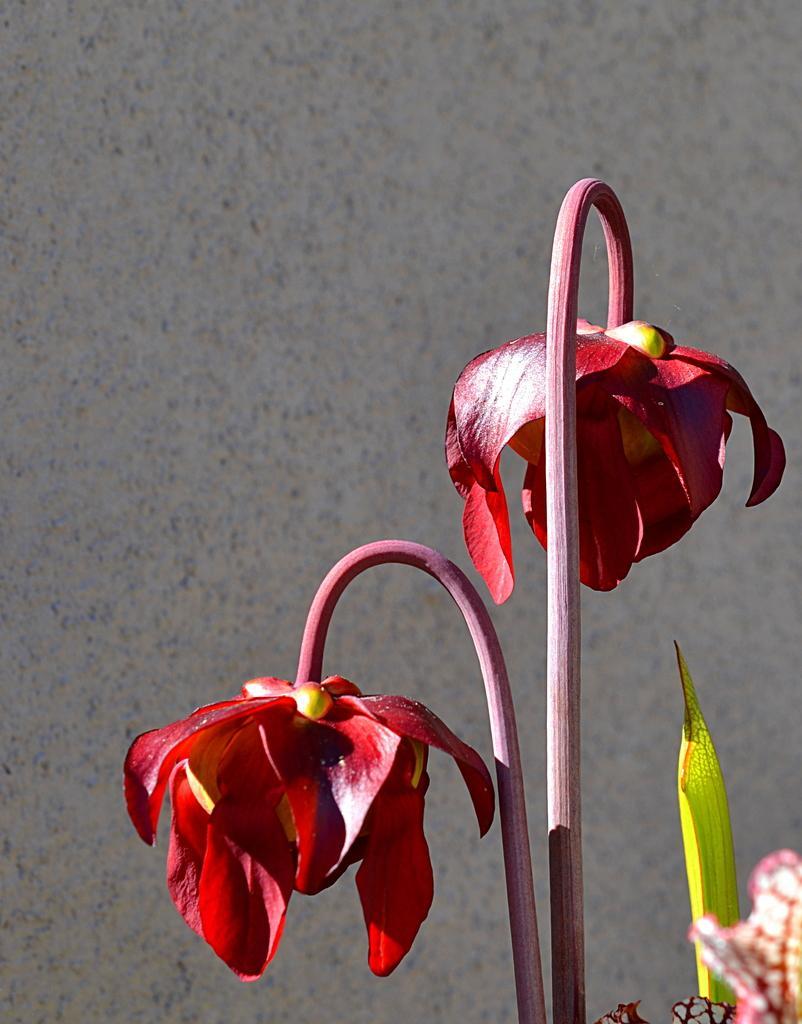How would you summarize this image in a sentence or two? In this picture we can see stems with flowers and in the background we can see the wall. 